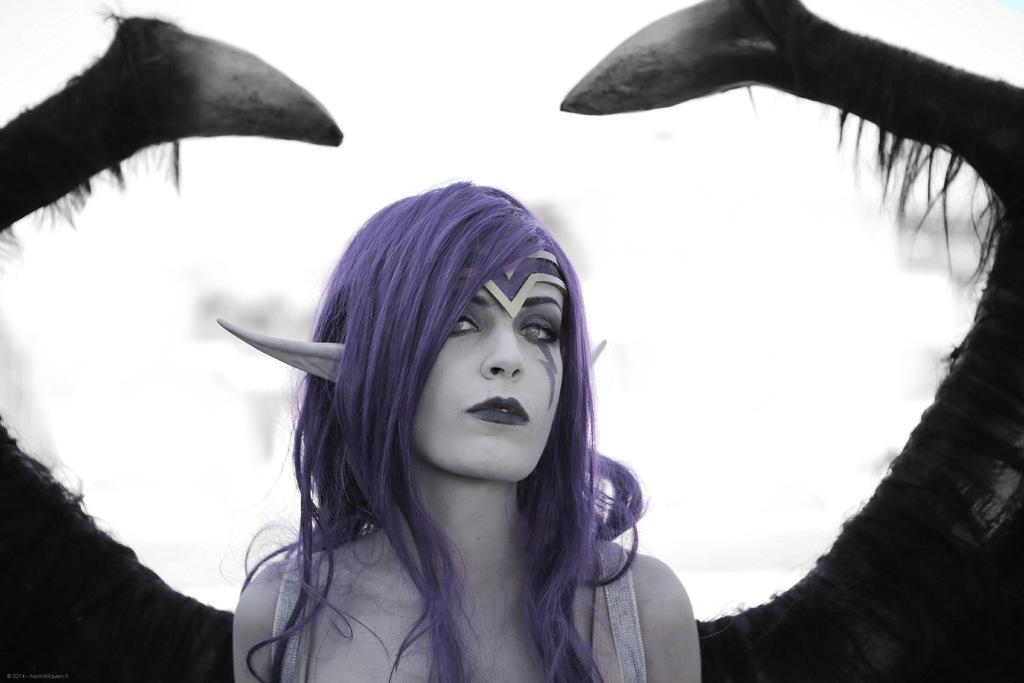In one or two sentences, can you explain what this image depicts? There is a person with blue hair presenting in this picture. 